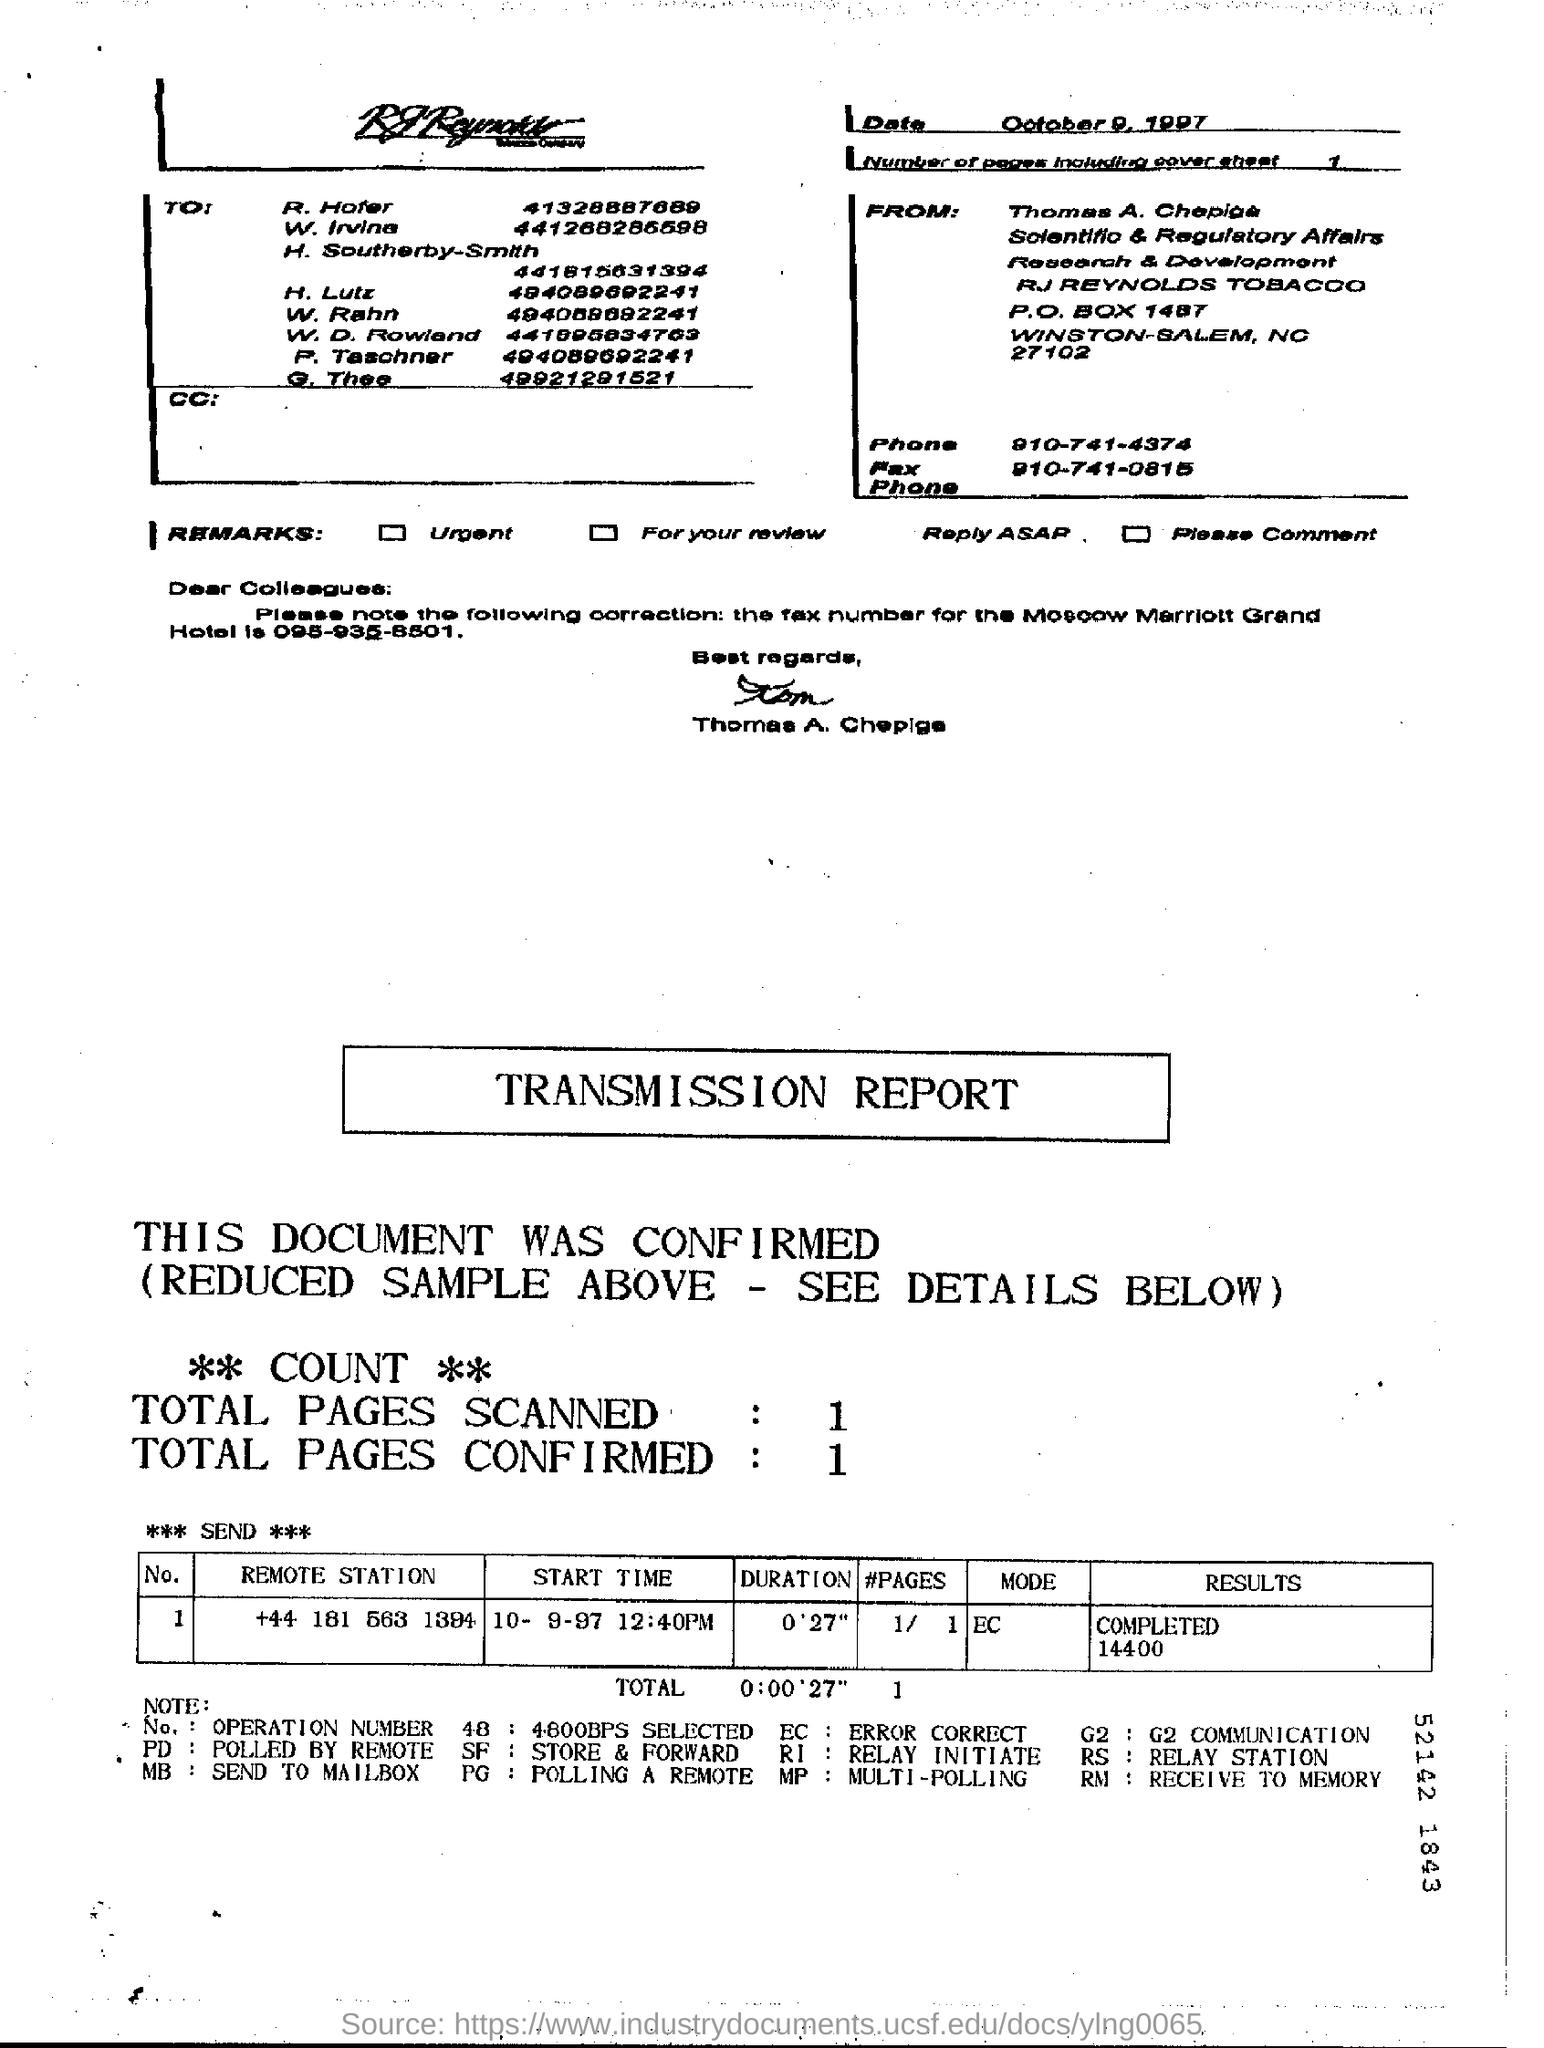Outline some significant characteristics in this image. The date on which the message was sent is October 9, 1997. 